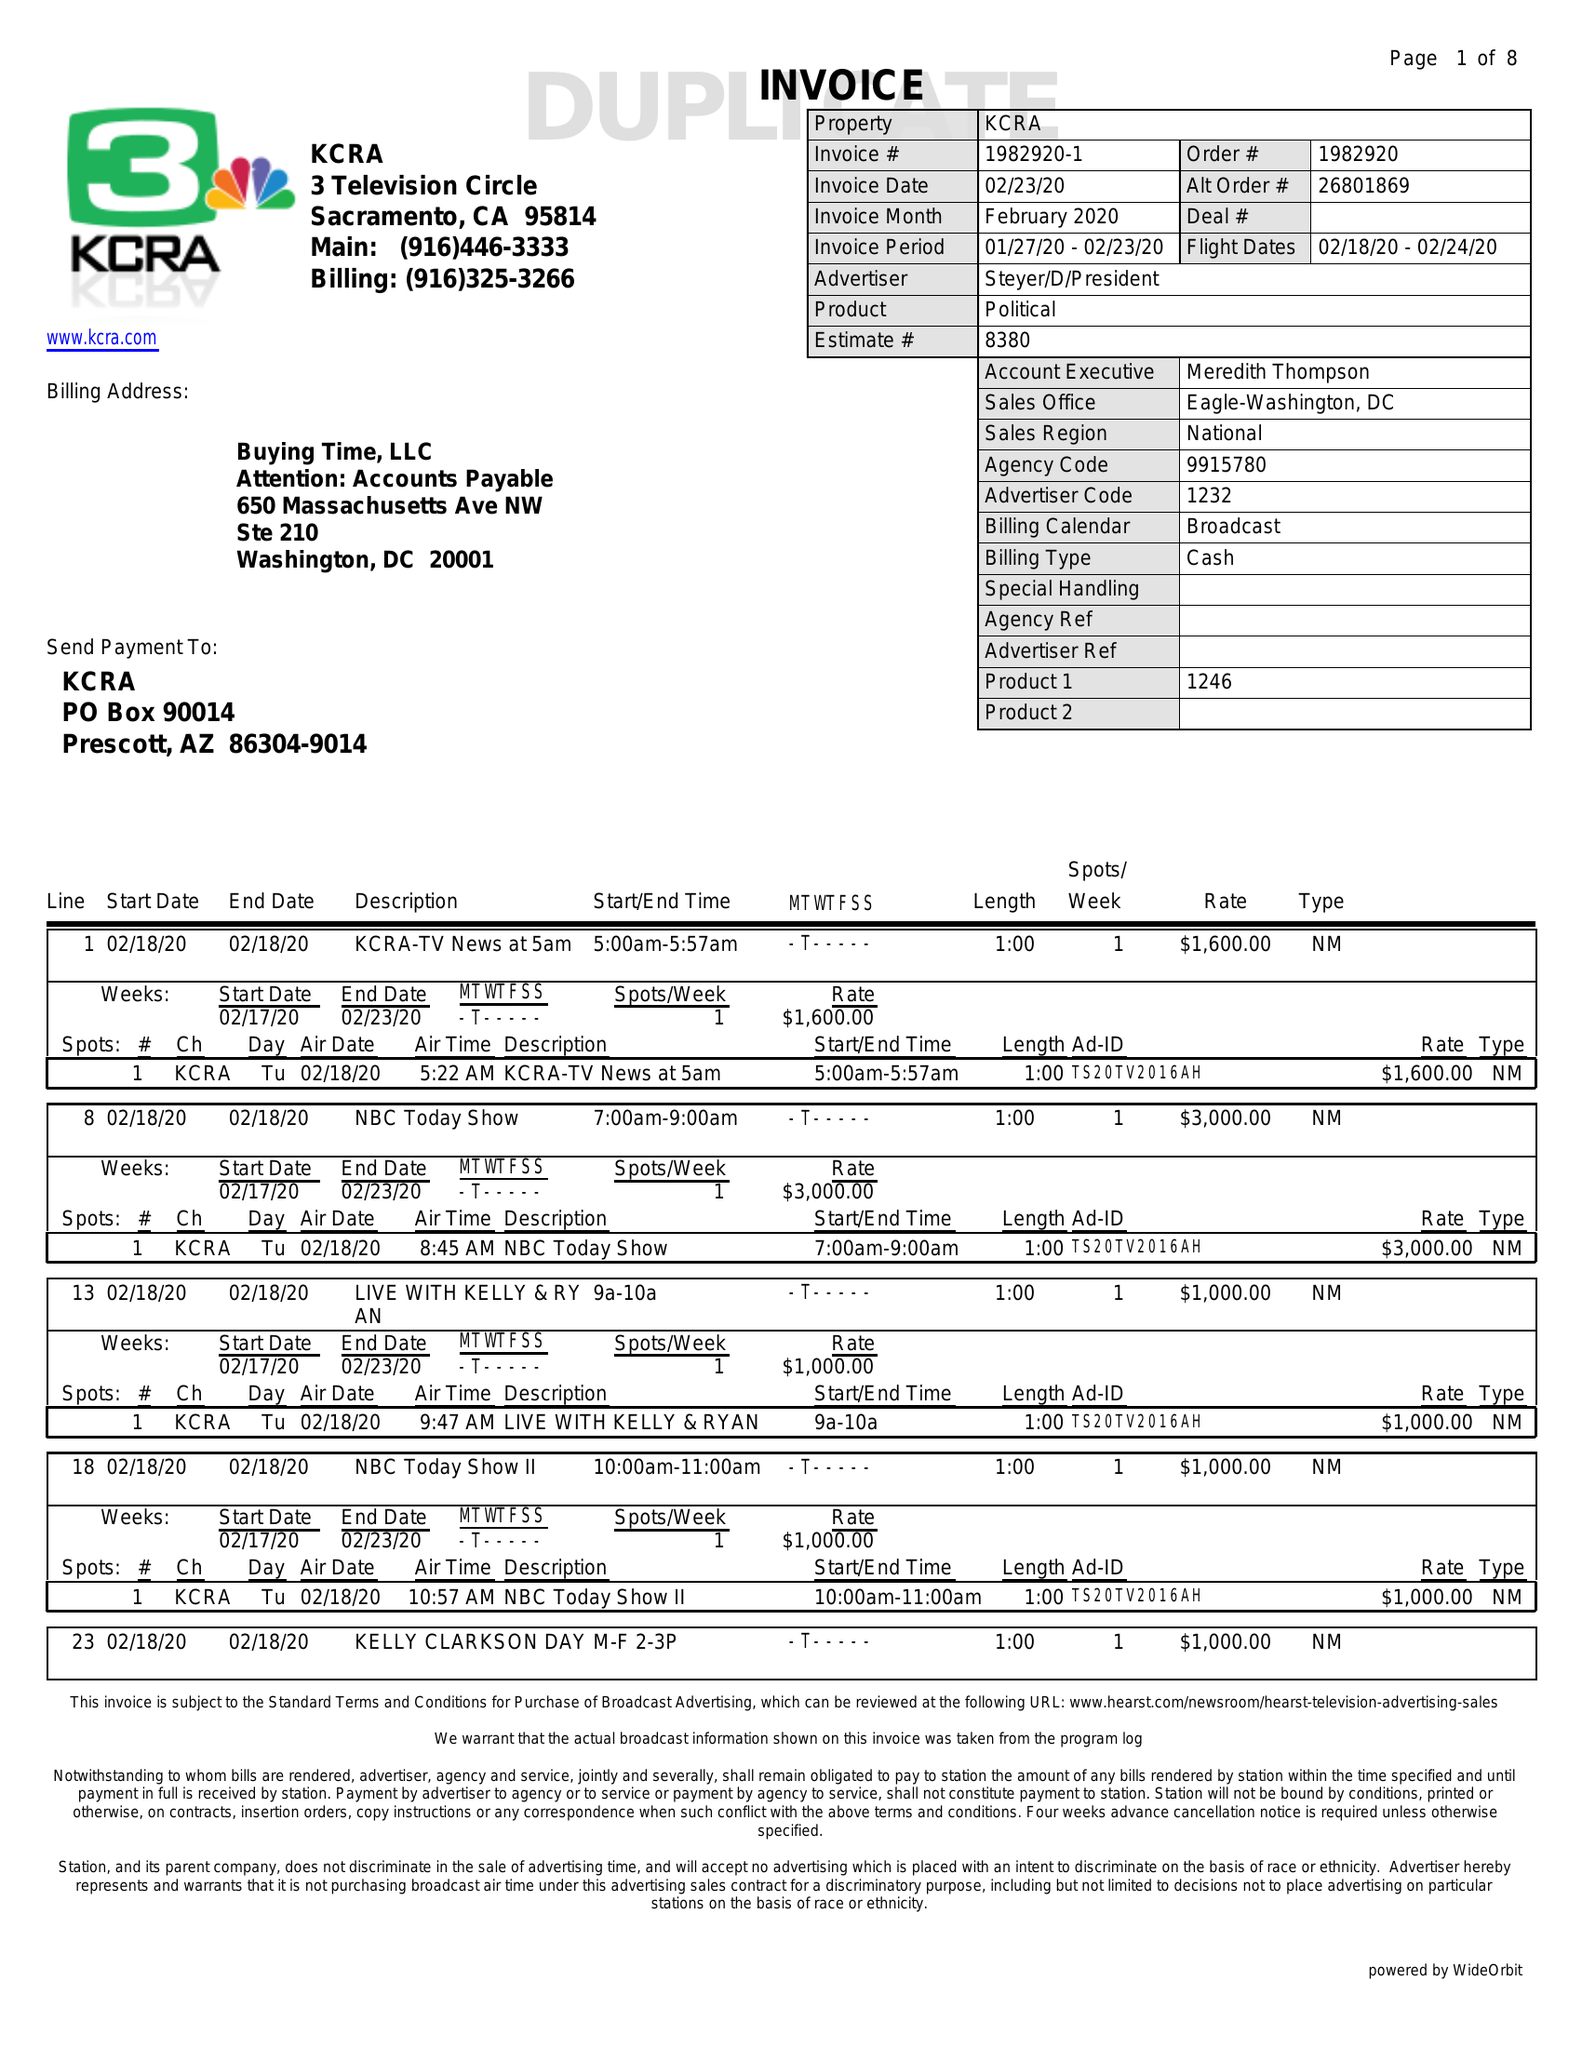What is the value for the gross_amount?
Answer the question using a single word or phrase. 63600.00 